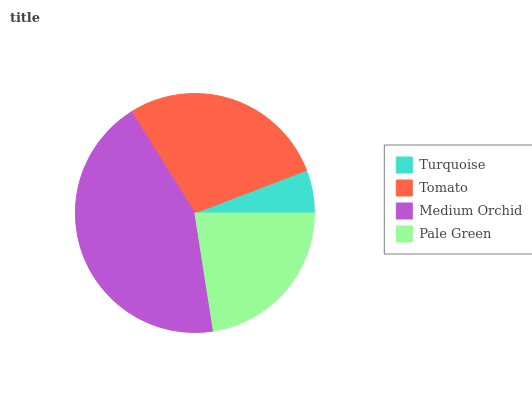Is Turquoise the minimum?
Answer yes or no. Yes. Is Medium Orchid the maximum?
Answer yes or no. Yes. Is Tomato the minimum?
Answer yes or no. No. Is Tomato the maximum?
Answer yes or no. No. Is Tomato greater than Turquoise?
Answer yes or no. Yes. Is Turquoise less than Tomato?
Answer yes or no. Yes. Is Turquoise greater than Tomato?
Answer yes or no. No. Is Tomato less than Turquoise?
Answer yes or no. No. Is Tomato the high median?
Answer yes or no. Yes. Is Pale Green the low median?
Answer yes or no. Yes. Is Pale Green the high median?
Answer yes or no. No. Is Medium Orchid the low median?
Answer yes or no. No. 